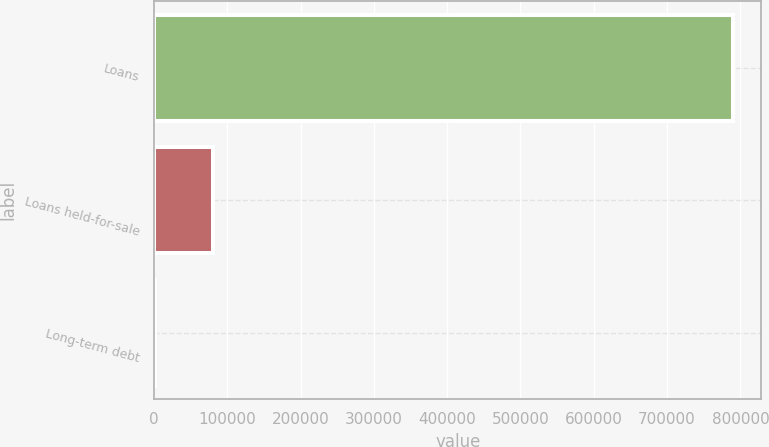<chart> <loc_0><loc_0><loc_500><loc_500><bar_chart><fcel>Loans<fcel>Loans held-for-sale<fcel>Long-term debt<nl><fcel>789273<fcel>80718.3<fcel>1990<nl></chart> 